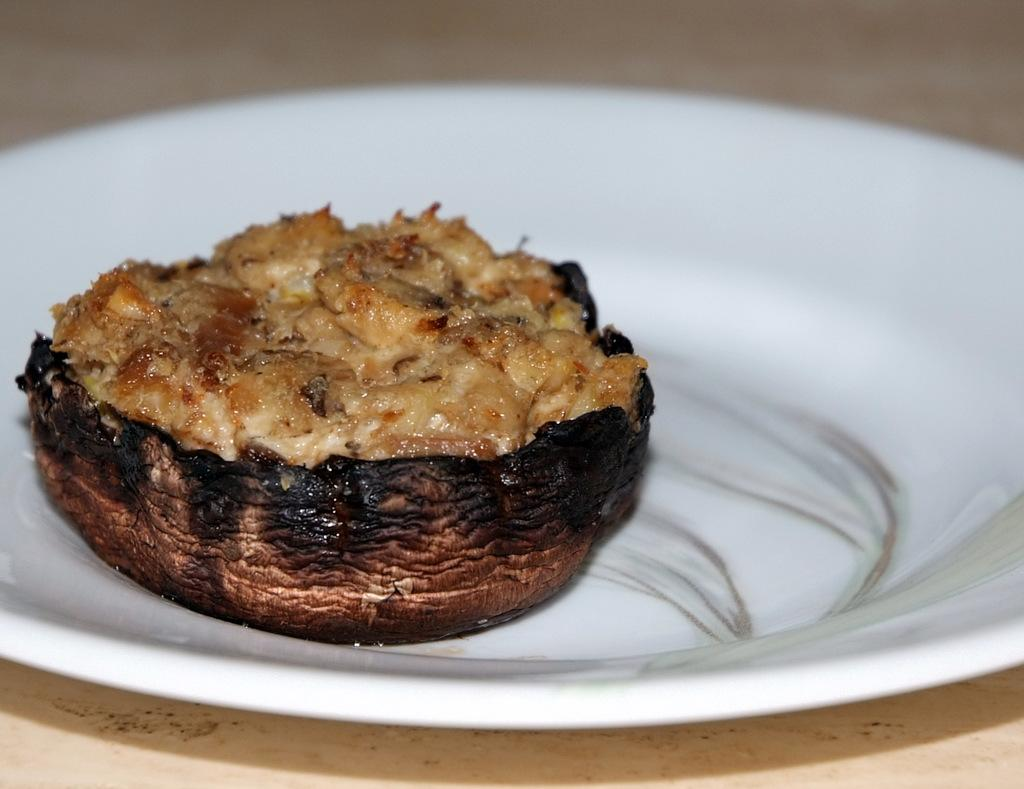What is located in the center of the image? There is a plate in the center of the image. What is on the plate? There is food on the plate. What type of surface is visible at the bottom of the image? There appears to be a table at the bottom of the image. What type of tin can be seen in the image? There is no tin present in the image. What type of leaf is visible on the plate? There is no leaf visible on the plate; it contains food. 